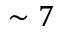<formula> <loc_0><loc_0><loc_500><loc_500>\sim 7</formula> 